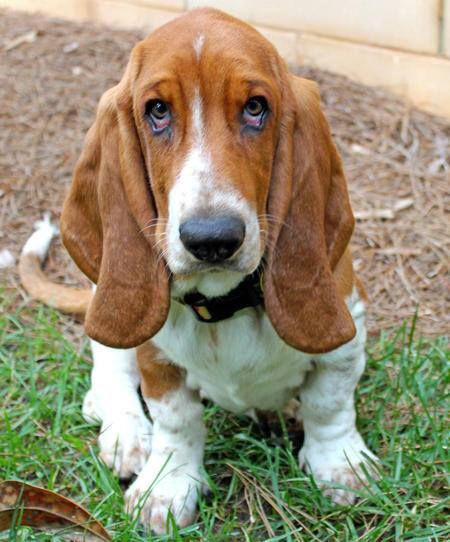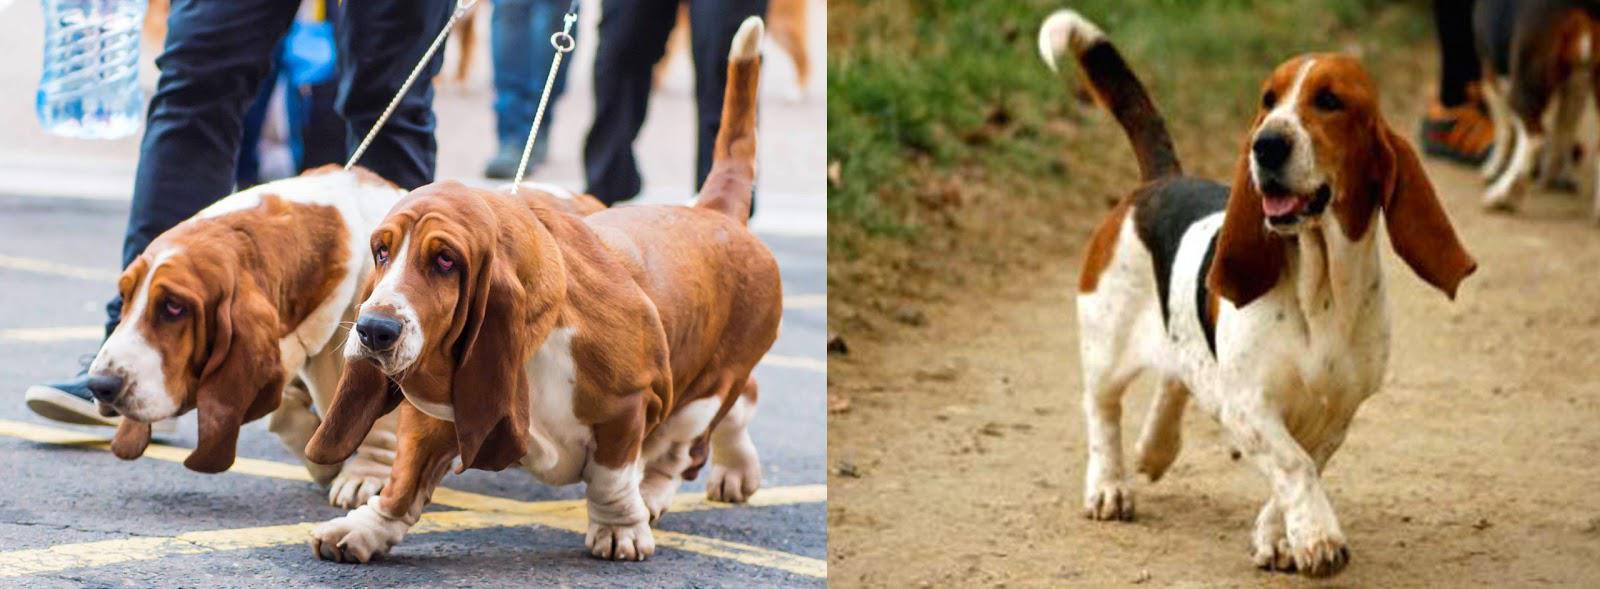The first image is the image on the left, the second image is the image on the right. Analyze the images presented: Is the assertion "There are fewer than four hounds here." valid? Answer yes or no. No. The first image is the image on the left, the second image is the image on the right. For the images shown, is this caption "At least one dog is resting its head." true? Answer yes or no. No. 